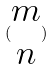<formula> <loc_0><loc_0><loc_500><loc_500>( \begin{matrix} m \\ n \end{matrix} )</formula> 